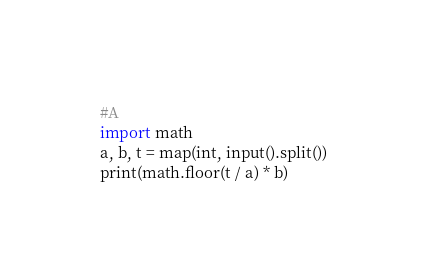<code> <loc_0><loc_0><loc_500><loc_500><_Python_>#A
import math
a, b, t = map(int, input().split())
print(math.floor(t / a) * b)
</code> 